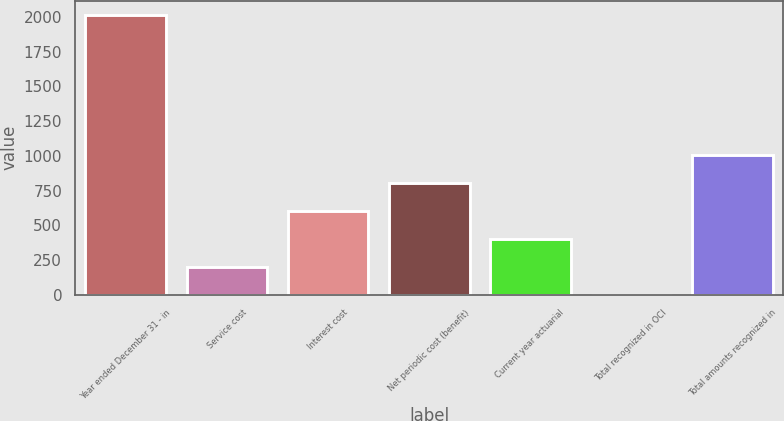Convert chart to OTSL. <chart><loc_0><loc_0><loc_500><loc_500><bar_chart><fcel>Year ended December 31 - in<fcel>Service cost<fcel>Interest cost<fcel>Net periodic cost (benefit)<fcel>Current year actuarial<fcel>Total recognized in OCI<fcel>Total amounts recognized in<nl><fcel>2016<fcel>203.4<fcel>606.2<fcel>807.6<fcel>404.8<fcel>2<fcel>1009<nl></chart> 